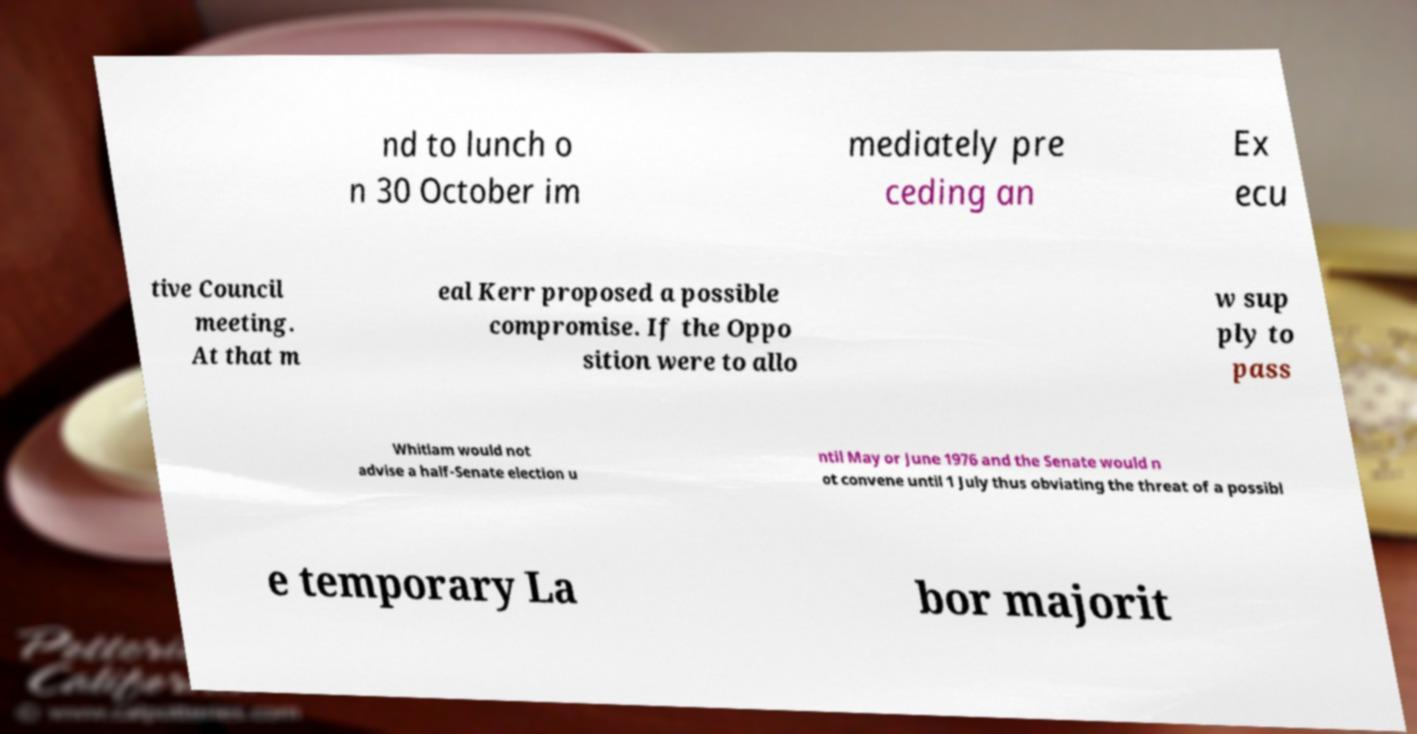Can you accurately transcribe the text from the provided image for me? nd to lunch o n 30 October im mediately pre ceding an Ex ecu tive Council meeting. At that m eal Kerr proposed a possible compromise. If the Oppo sition were to allo w sup ply to pass Whitlam would not advise a half-Senate election u ntil May or June 1976 and the Senate would n ot convene until 1 July thus obviating the threat of a possibl e temporary La bor majorit 